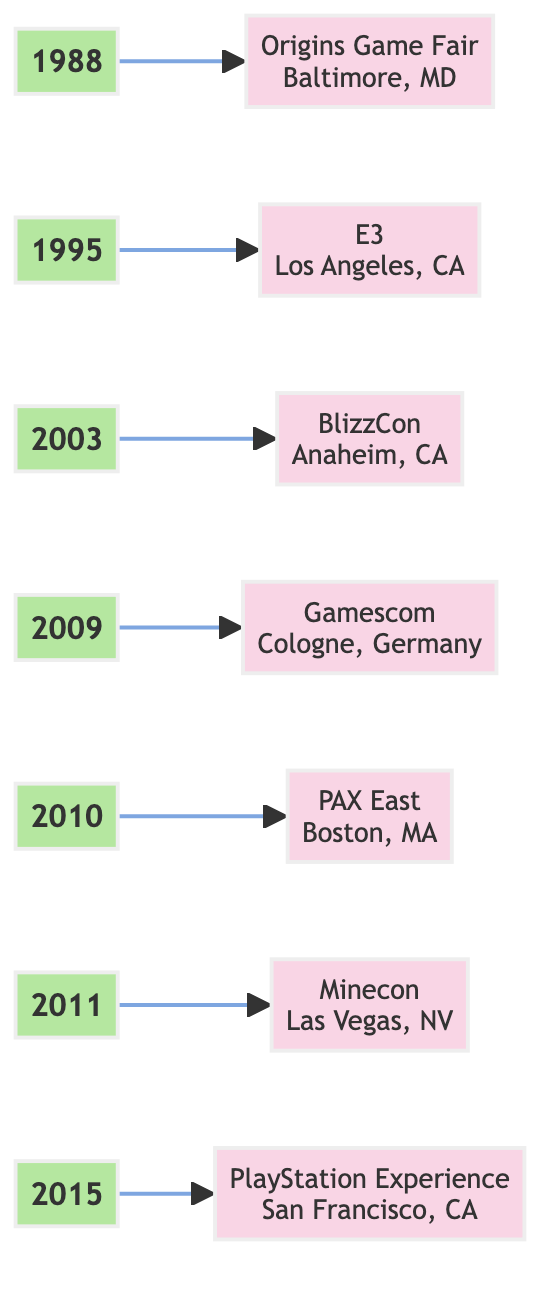What year did the Origins Game Fair take place? The diagram shows "1988" linked to "Origins Game Fair," indicating that this event occurred in 1988.
Answer: 1988 How many major gaming conventions are represented in the diagram? By counting the distinct years listed from 1988 to 2015, we can identify a total of 7 major gaming conventions in the diagram.
Answer: 7 Which convention is associated with the year 2010? The flow from the year "2010" leads to "PAX East," meaning that PAX East is the convention associated with this year.
Answer: PAX East What city hosted E3 in 1995? The diagram shows the event "E3" branched from the year "1995" and indicates it took place in "Los Angeles, CA."
Answer: Los Angeles, CA From which city did BlizzCon originate? The year "2003" flows to "BlizzCon," which is noted as being held in "Anaheim, CA." Therefore, the city of origin for BlizzCon is Anaheim.
Answer: Anaheim, CA Which event first focused on Minecraft? The diagram connects "2011" to "Minecon," which is specifically mentioned as initially focusing on Minecraft.
Answer: Minecon Which convention followed Gamescom in the timeline? The flowchart indicates that after "Gamescom" takes place in "2009," the next event shown is "PAX East" in "2010," making PAX East the following event.
Answer: PAX East What is the primary focus of the PlayStation Experience event? The description linked to "PlayStation Experience" states that it showcases "upcoming titles and exclusive content related to PlayStation," which indicates its primary focus.
Answer: Upcoming titles and exclusive content related to PlayStation In which year did the largest gaming convention in Europe, Gamescom, take place? The diagram shows Gamescom occurring in "2009," directly answering the question about the year it took place.
Answer: 2009 Which event is centered around Blizzard Entertainment's franchises? The diagram indicates that "BlizzCon," connected to "2003," is centered around major franchises from Blizzard Entertainment.
Answer: BlizzCon 